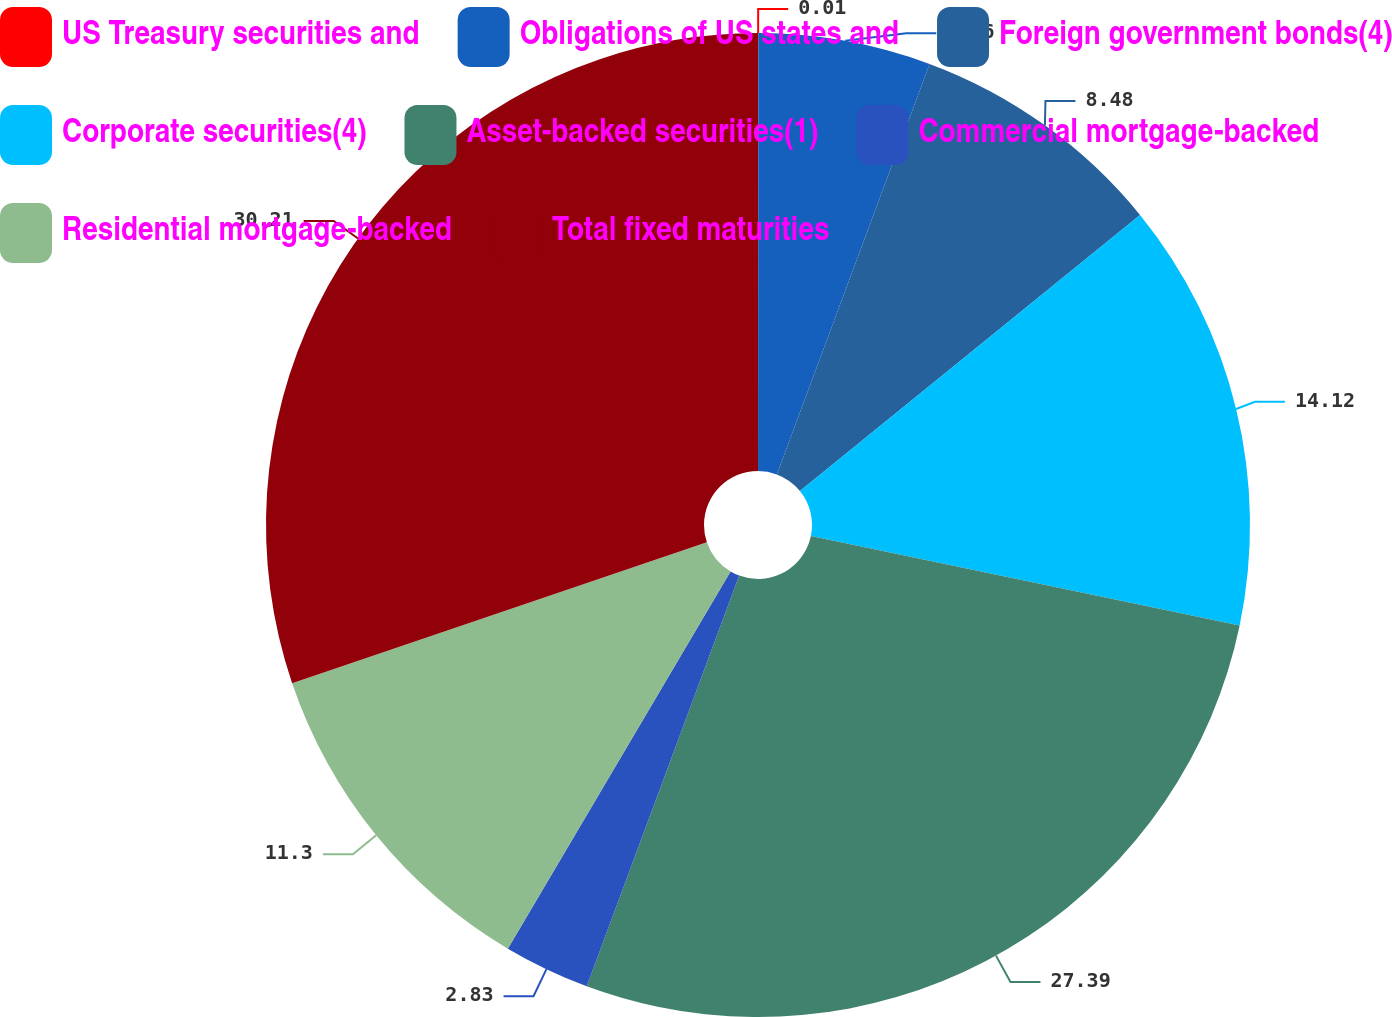Convert chart to OTSL. <chart><loc_0><loc_0><loc_500><loc_500><pie_chart><fcel>US Treasury securities and<fcel>Obligations of US states and<fcel>Foreign government bonds(4)<fcel>Corporate securities(4)<fcel>Asset-backed securities(1)<fcel>Commercial mortgage-backed<fcel>Residential mortgage-backed<fcel>Total fixed maturities<nl><fcel>0.01%<fcel>5.66%<fcel>8.48%<fcel>14.12%<fcel>27.39%<fcel>2.83%<fcel>11.3%<fcel>30.21%<nl></chart> 